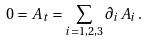Convert formula to latex. <formula><loc_0><loc_0><loc_500><loc_500>0 = A _ { t } = \sum _ { i = 1 , 2 , 3 } \partial _ { i } A _ { i } \, .</formula> 